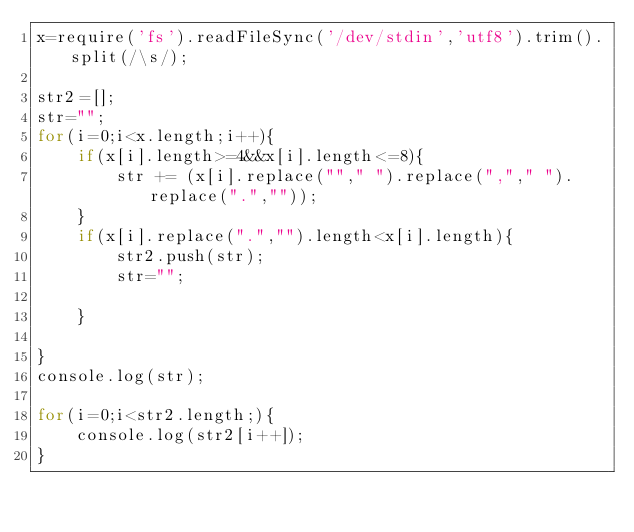<code> <loc_0><loc_0><loc_500><loc_500><_JavaScript_>x=require('fs').readFileSync('/dev/stdin','utf8').trim().split(/\s/);

str2=[];
str="";
for(i=0;i<x.length;i++){
    if(x[i].length>=4&&x[i].length<=8){
        str += (x[i].replace(""," ").replace(","," ").replace(".",""));
    }
    if(x[i].replace(".","").length<x[i].length){
        str2.push(str);
        str="";
        
    }
    
}
console.log(str);

for(i=0;i<str2.length;){
    console.log(str2[i++]);
}</code> 